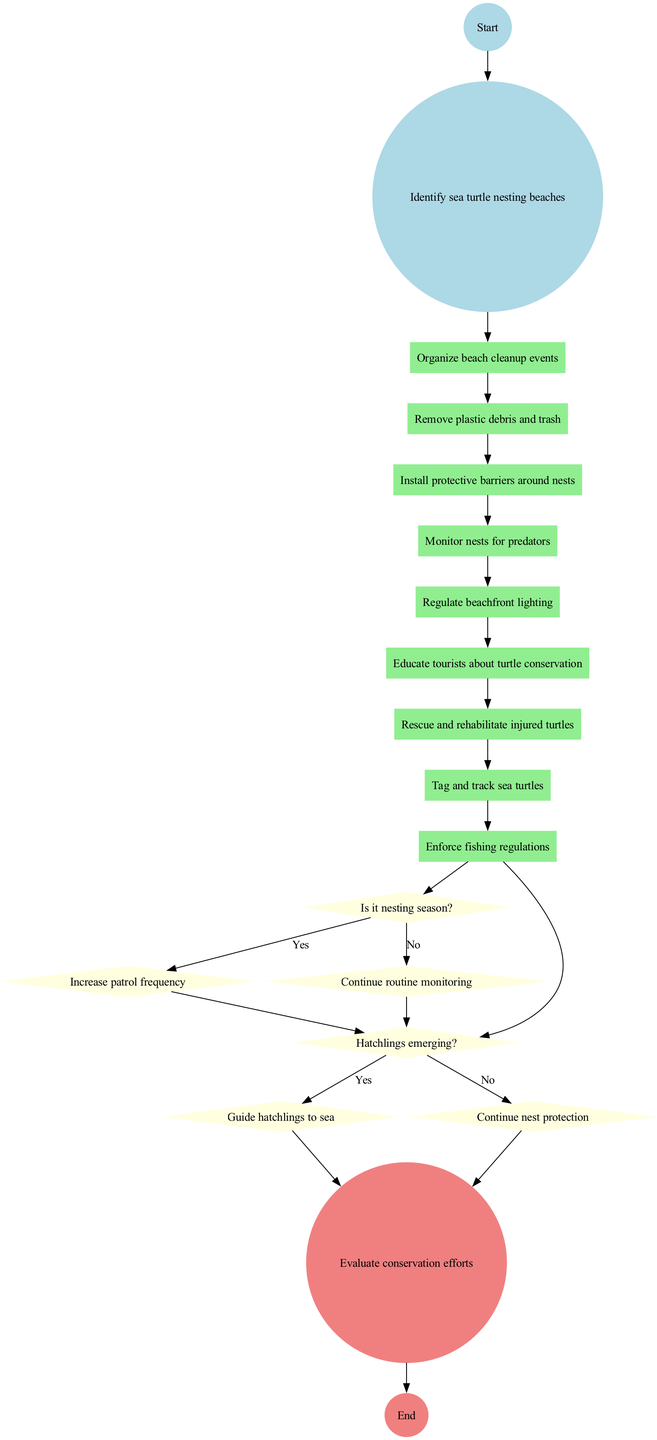What is the starting activity in the diagram? The diagram begins with the initial node, which states "Identify sea turtle nesting beaches." This is the first activity before any other actions are taken.
Answer: Identify sea turtle nesting beaches How many activities are listed in the diagram? Counting the different activities shown, there are a total of nine activities in the diagram.
Answer: 9 What happens if it's nesting season? When the condition "Is it nesting season?" is answered yes, the next action indicated is "Increase patrol frequency," which shows the response to this situation.
Answer: Increase patrol frequency What is the last activity before evaluating conservation efforts? The final activity before reaching the evaluation stage is determined by inspecting the flow of the diagram, which indicates that the last action is "Continue nest protection."
Answer: Continue nest protection What action is taken if hatchlings are emerging? If the condition "Hatchlings emerging?" is answered yes, the diagram indicates that the action to be taken is "Guide hatchlings to sea."
Answer: Guide hatchlings to sea Which condition leads to guiding hatchlings to the sea? The condition that leads to guiding hatchlings to the sea is when "Hatchlings emerging?" is answered yes; this triggers the corresponding action directly according to the flow of the diagram.
Answer: Hatchlings emerging? What step follows after rescuing and rehabilitating injured turtles? After "Rescue and rehabilitate injured turtles," the diagram indicates that the next action is to "Tag and track sea turtles," showing a sequential flow of activities.
Answer: Tag and track sea turtles How many decision points are present in the diagram? The diagram contains two decision points, which determine further actions based on the conditions provided.
Answer: 2 What is the final node in the activity diagram? The final node of the diagram is labeled "Evaluate conservation efforts," and it indicates the conclusion of the activities and the assessments made thereafter.
Answer: Evaluate conservation efforts 